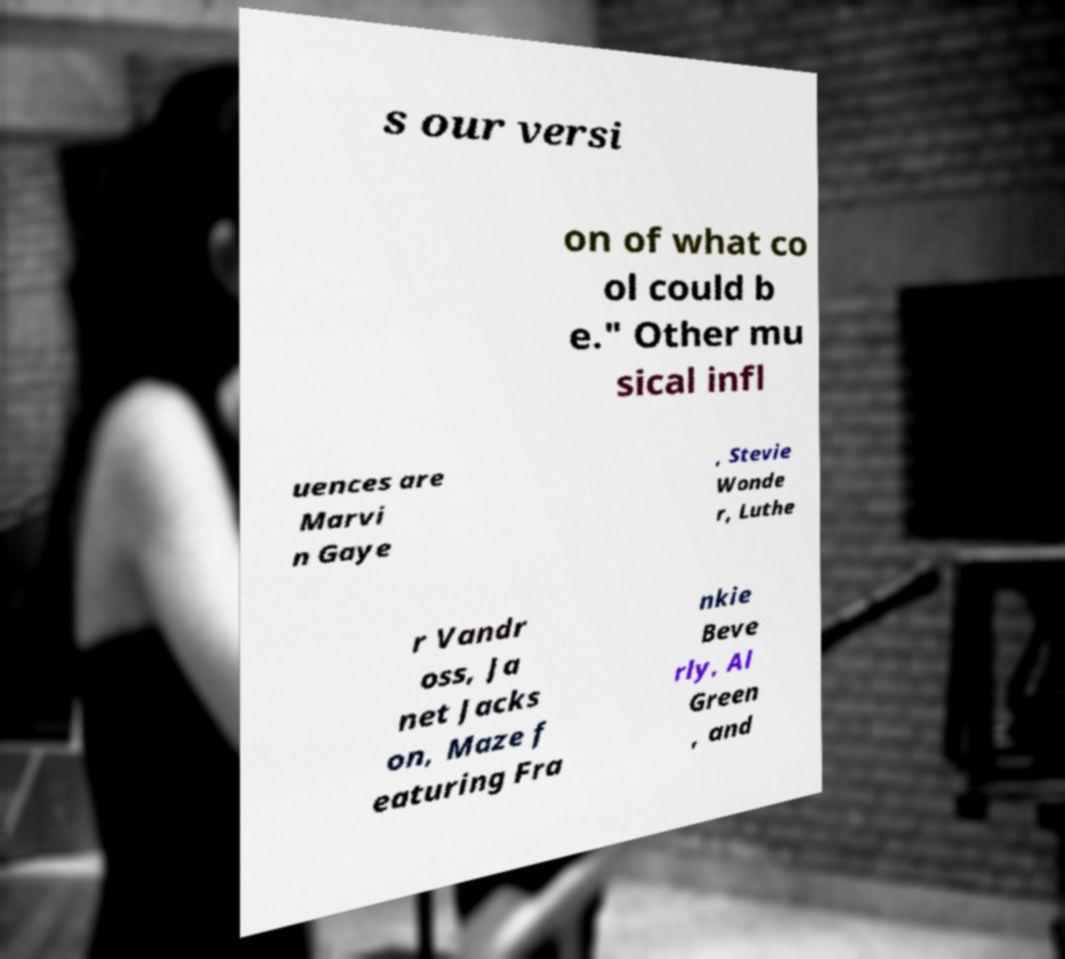What messages or text are displayed in this image? I need them in a readable, typed format. s our versi on of what co ol could b e." Other mu sical infl uences are Marvi n Gaye , Stevie Wonde r, Luthe r Vandr oss, Ja net Jacks on, Maze f eaturing Fra nkie Beve rly, Al Green , and 